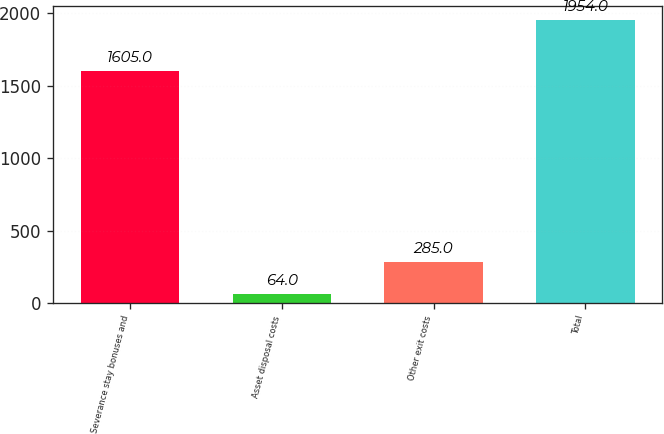<chart> <loc_0><loc_0><loc_500><loc_500><bar_chart><fcel>Severance stay bonuses and<fcel>Asset disposal costs<fcel>Other exit costs<fcel>Total<nl><fcel>1605<fcel>64<fcel>285<fcel>1954<nl></chart> 